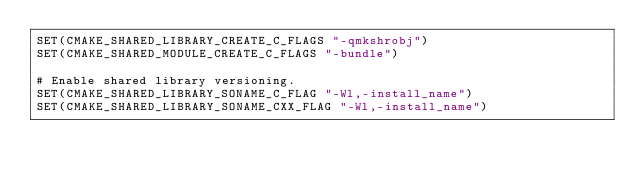Convert code to text. <code><loc_0><loc_0><loc_500><loc_500><_CMake_>SET(CMAKE_SHARED_LIBRARY_CREATE_C_FLAGS "-qmkshrobj")
SET(CMAKE_SHARED_MODULE_CREATE_C_FLAGS "-bundle")

# Enable shared library versioning.
SET(CMAKE_SHARED_LIBRARY_SONAME_C_FLAG "-Wl,-install_name")
SET(CMAKE_SHARED_LIBRARY_SONAME_CXX_FLAG "-Wl,-install_name")
</code> 